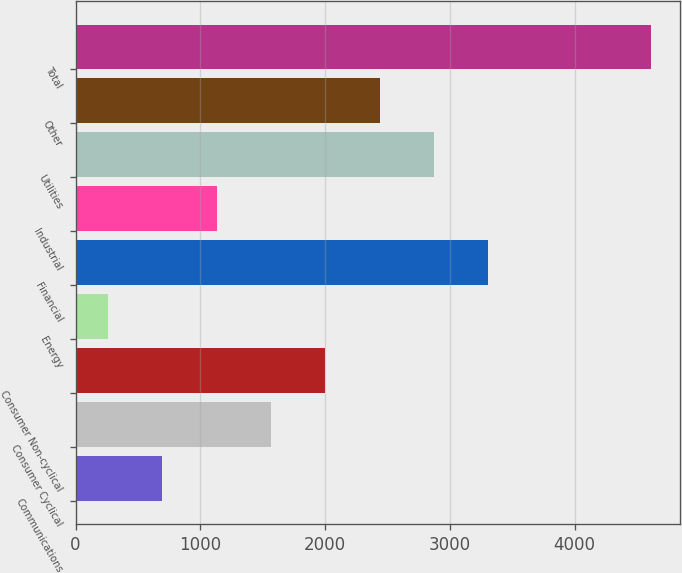Convert chart. <chart><loc_0><loc_0><loc_500><loc_500><bar_chart><fcel>Communications<fcel>Consumer Cyclical<fcel>Consumer Non-cyclical<fcel>Energy<fcel>Financial<fcel>Industrial<fcel>Utilities<fcel>Other<fcel>Total<nl><fcel>694.5<fcel>1565.5<fcel>2001<fcel>259<fcel>3307.5<fcel>1130<fcel>2872<fcel>2436.5<fcel>4614<nl></chart> 